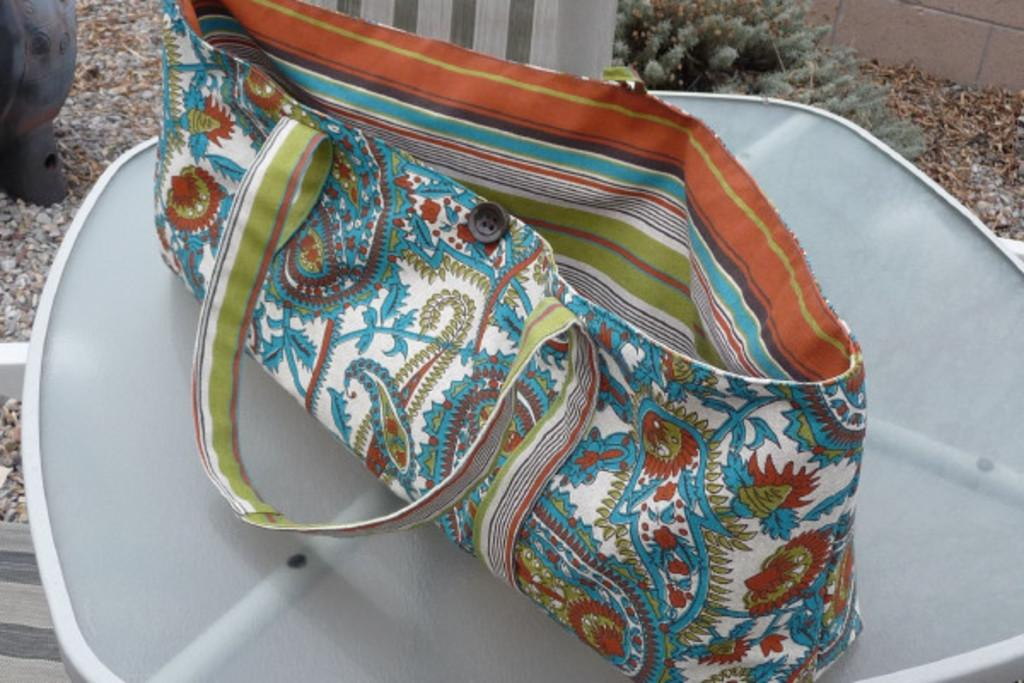What is on the table in the image? There is a bag on the table in the image. What are the features of the bag? The bag has straps and a button. What can be seen in the background of the image? Soil and stones are visible in the background. Is there an ornament hanging from the bag in the image? There is no ornament hanging from the bag in the image. How many men can be seen in the image? There are no men present in the image. 